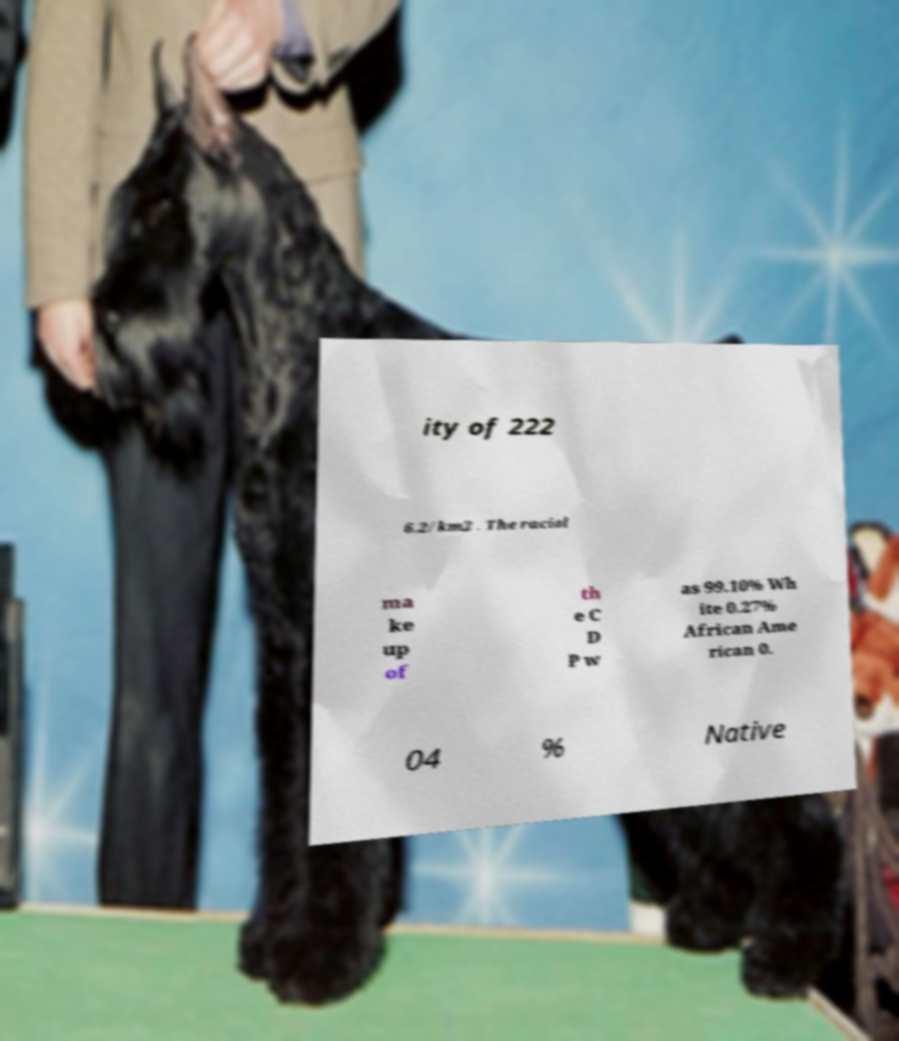There's text embedded in this image that I need extracted. Can you transcribe it verbatim? ity of 222 6.2/km2 . The racial ma ke up of th e C D P w as 99.10% Wh ite 0.27% African Ame rican 0. 04 % Native 